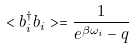<formula> <loc_0><loc_0><loc_500><loc_500>< b _ { i } ^ { \dagger } b _ { i } > = \frac { 1 } { e ^ { \beta \omega _ { i } } - q }</formula> 